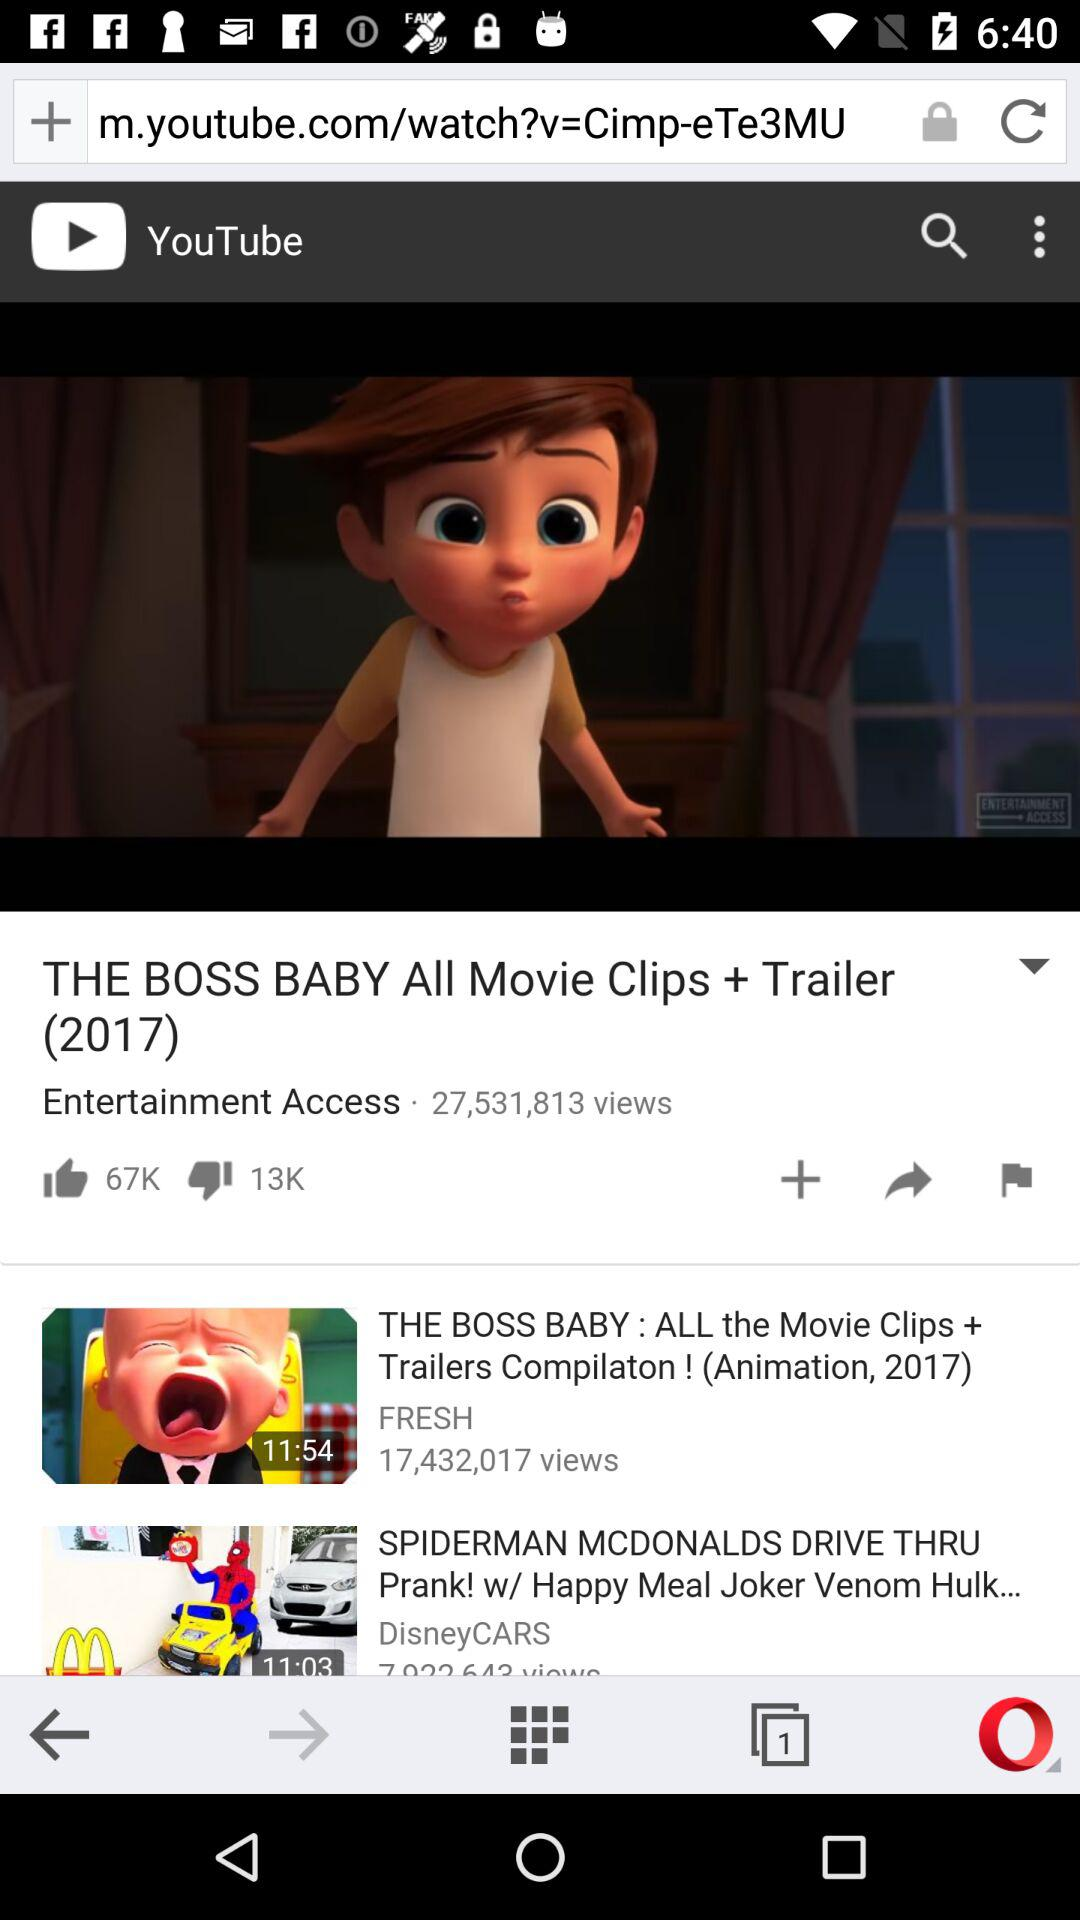How many views does the video with the most views have?
Answer the question using a single word or phrase. 27,531,813 